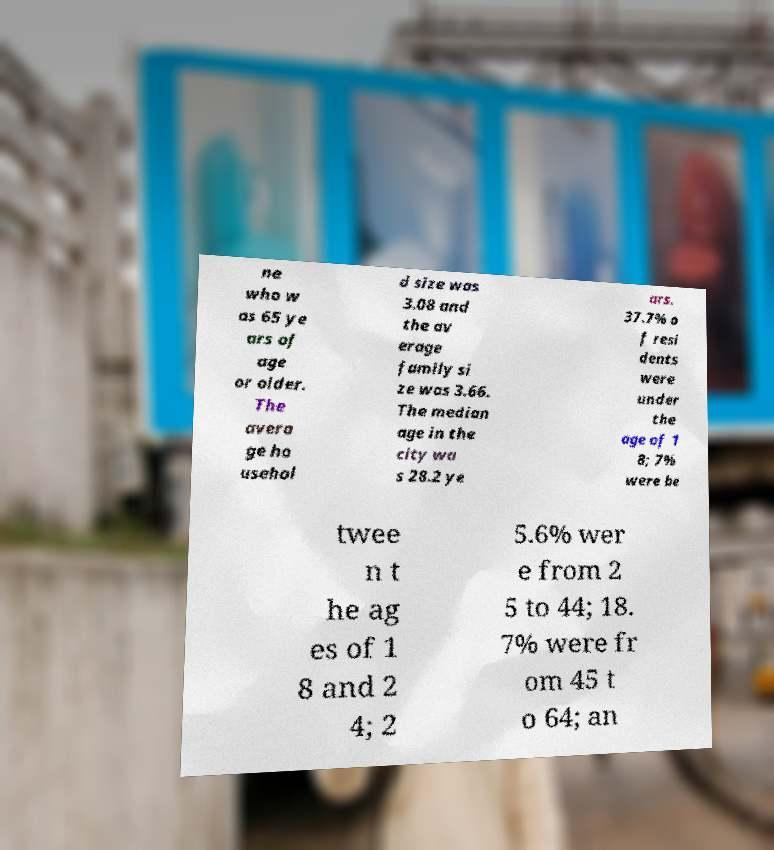What messages or text are displayed in this image? I need them in a readable, typed format. ne who w as 65 ye ars of age or older. The avera ge ho usehol d size was 3.08 and the av erage family si ze was 3.66. The median age in the city wa s 28.2 ye ars. 37.7% o f resi dents were under the age of 1 8; 7% were be twee n t he ag es of 1 8 and 2 4; 2 5.6% wer e from 2 5 to 44; 18. 7% were fr om 45 t o 64; an 